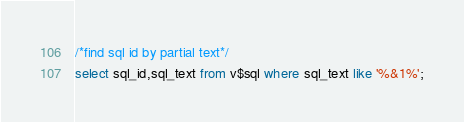Convert code to text. <code><loc_0><loc_0><loc_500><loc_500><_SQL_>/*find sql id by partial text*/
select sql_id,sql_text from v$sql where sql_text like '%&1%';</code> 